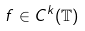<formula> <loc_0><loc_0><loc_500><loc_500>f \in C ^ { k } ( \mathbb { T } )</formula> 